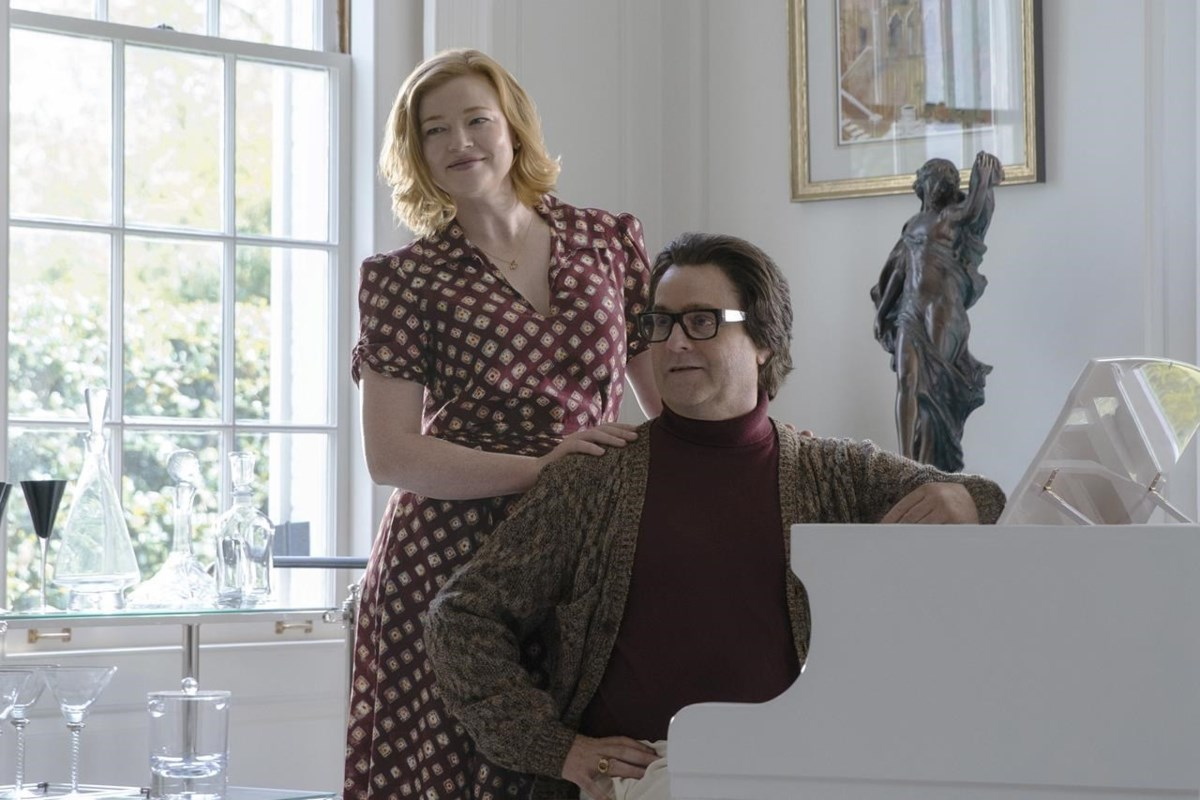What might be happening in this scene? Provide a detailed scenario. Imagine a serene Sunday afternoon where the two characters are taking a break from their daily routines. The man at the piano has decided to play a beloved tune that fills the room with melody. His companion is drawn by the music and stands beside him, both sharing a moment of pure joy and nostalgia. The natural light streaming through the grand window casts a soft glow, making the white curtains shimmer slightly. The statue in the background adds an artistic milieu, perhaps suggesting that this room is a sanctuary filled with art and culture, offering a perfect haven for moments of creativity and connection. 